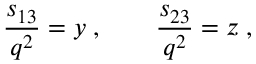Convert formula to latex. <formula><loc_0><loc_0><loc_500><loc_500>\frac { s _ { 1 3 } } { q ^ { 2 } } = y \, , \quad \frac { s _ { 2 3 } } { q ^ { 2 } } = z \, ,</formula> 